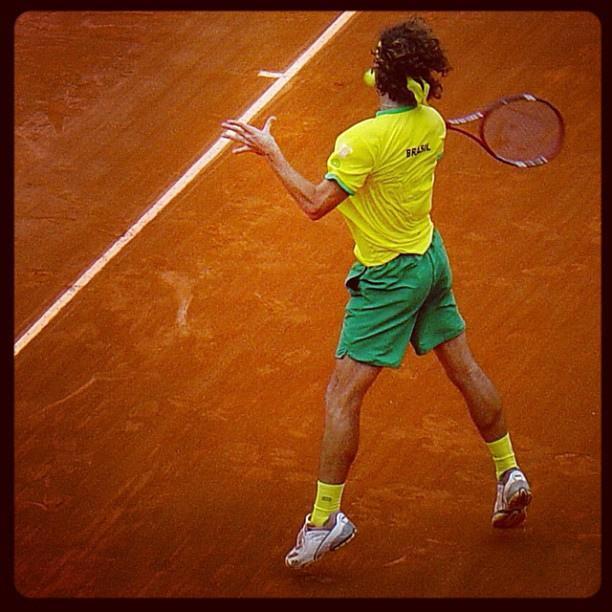How many chocolate donuts are there in this image ?
Give a very brief answer. 0. 